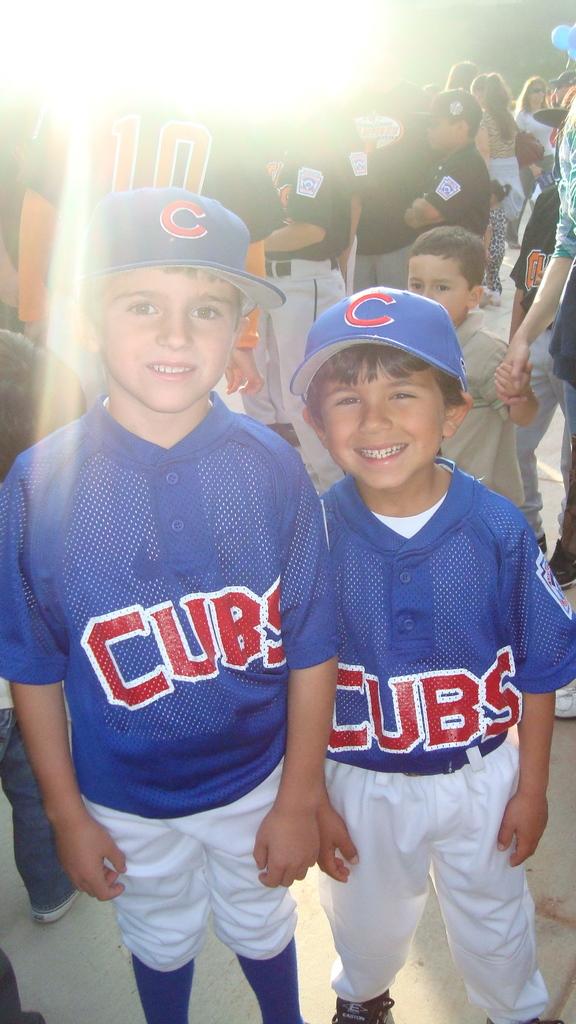What team do the boys play for?
Provide a short and direct response. Cubs. 